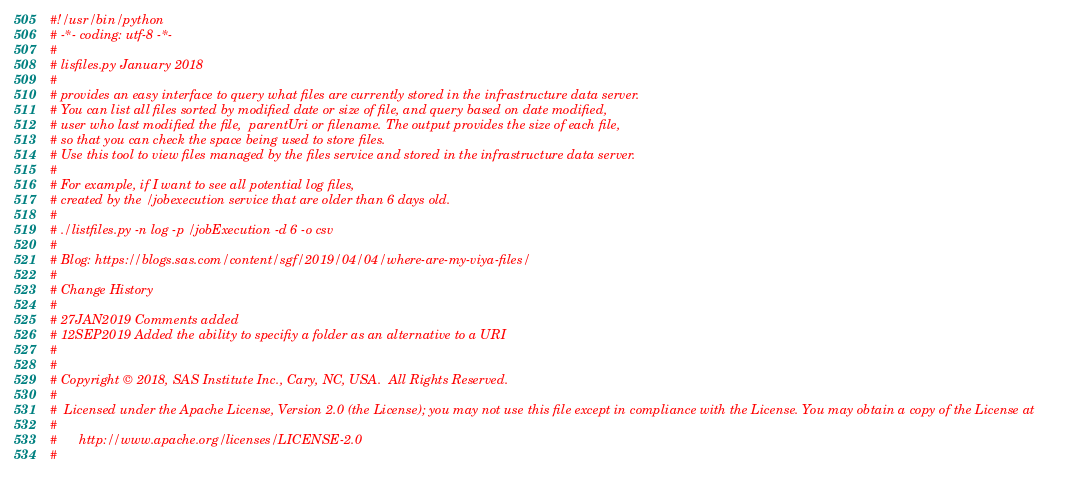<code> <loc_0><loc_0><loc_500><loc_500><_Python_>#!/usr/bin/python
# -*- coding: utf-8 -*-
#
# lisfiles.py January 2018
#
# provides an easy interface to query what files are currently stored in the infrastructure data server.
# You can list all files sorted by modified date or size of file, and query based on date modified,
# user who last modified the file,  parentUri or filename. The output provides the size of each file, 
# so that you can check the space being used to store files. 
# Use this tool to view files managed by the files service and stored in the infrastructure data server.
#
# For example, if I want to see all potential log files, 
# created by the /jobexecution service that are older than 6 days old.
#
# ./listfiles.py -n log -p /jobExecution -d 6 -o csv
#
# Blog: https://blogs.sas.com/content/sgf/2019/04/04/where-are-my-viya-files/ 
#
# Change History
#
# 27JAN2019 Comments added
# 12SEP2019 Added the ability to specifiy a folder as an alternative to a URI
#
#
# Copyright © 2018, SAS Institute Inc., Cary, NC, USA.  All Rights Reserved.
#
#  Licensed under the Apache License, Version 2.0 (the License); you may not use this file except in compliance with the License. You may obtain a copy of the License at
#
#      http://www.apache.org/licenses/LICENSE-2.0
#</code> 